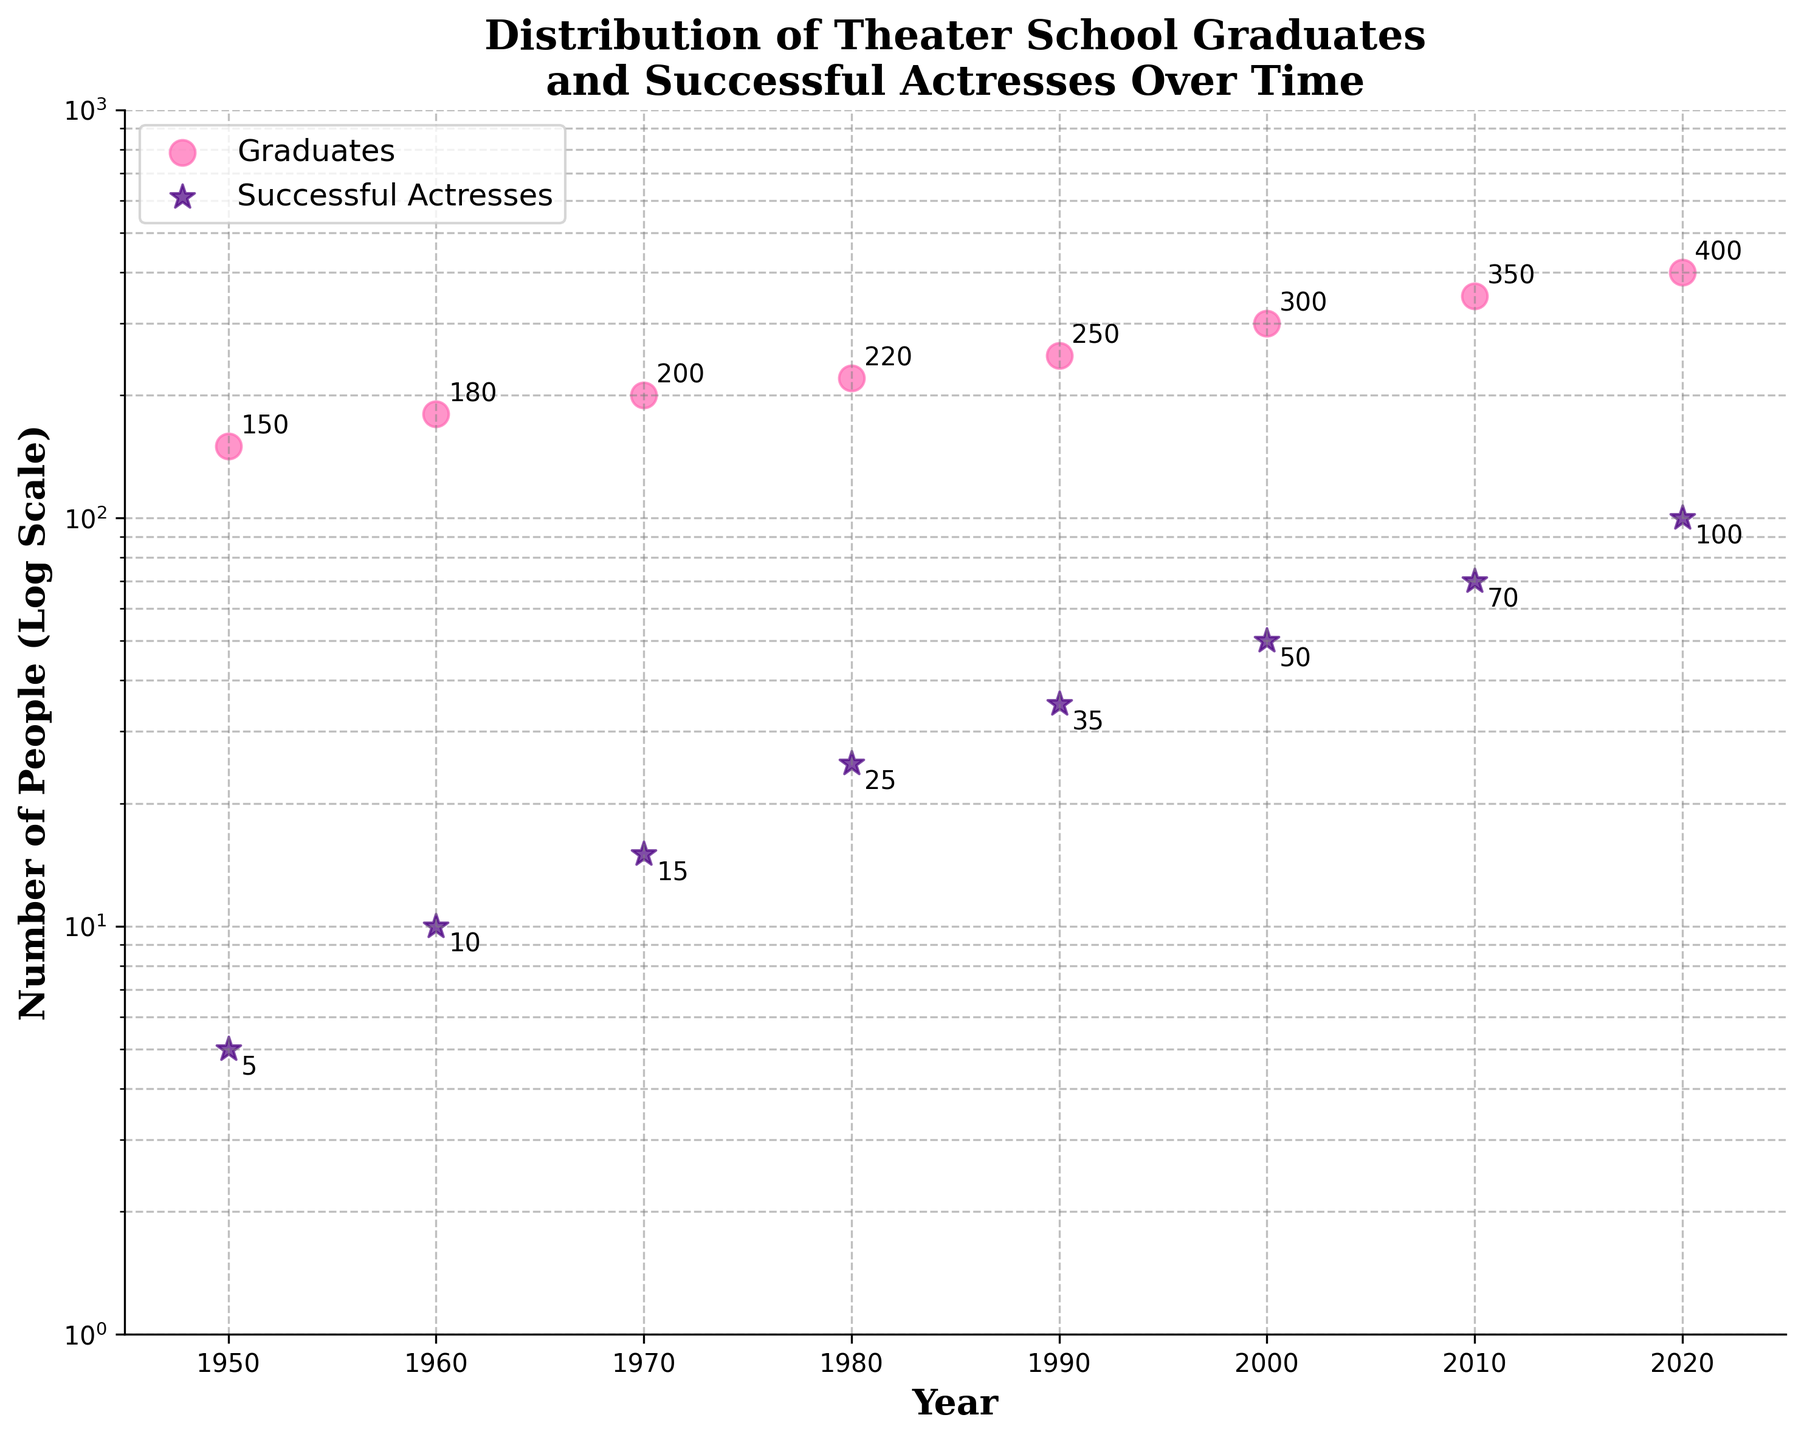What is the title of the figure? The title is usually located at the top of the figure and helps to describe the overall content.
Answer: Distribution of Theater School Graduates and Successful Actresses Over Time How many data points are shown for the number of Successful Actresses? This can be determined by counting the number of star markers on the plot.
Answer: 8 What are the two categories in the figure represented by different markers? Identify the markers and their corresponding categories from the legend near the plot.
Answer: Graduates and Successful Actresses What is the number of Graduates in 1980? Locate the point on the scatter plot corresponding to the year 1980 and find the value for the pink circle marker.
Answer: 220 Between which years did the number of Successful Actresses experience the largest increase? Compare the differences in y-values of the star markers between the years to identify the largest increase.
Answer: 2000 to 2010 What is the approximate ratio of Successful Actresses to Graduates in the year 2020? Find the values for both categories in 2020 and calculate the ratio by dividing the number of Successful Actresses by the number of Graduates.
Answer: 100/400 = 0.25 On which year did the number of Graduates first exceed 200? Identify the point where the number of Graduates (pink circles) crosses 200 along the y-axis.
Answer: 1970 Which year has the highest number of Successful Actresses? Identify the year by finding the highest point of the star markers along the y-axis.
Answer: 2020 What is the trend observed in the number of Graduates over time? Examine how the pink circle markers move from left to right along the x-axis, focusing on whether they increase, decrease, or remain stable.
Answer: Increasing If you compare the ratio of Successful Actresses to Graduates in 1950 and 2020, how does it change? Calculate the ratios for both years and compare: (Successful Actresses / Graduates for 1950 and 2020).
Answer: It increases from 0.033 in 1950 to 0.25 in 2020 